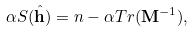Convert formula to latex. <formula><loc_0><loc_0><loc_500><loc_500>\alpha S ( \hat { \mathbf h } ) = n - \alpha T r ( { \mathbf M } ^ { - 1 } ) ,</formula> 